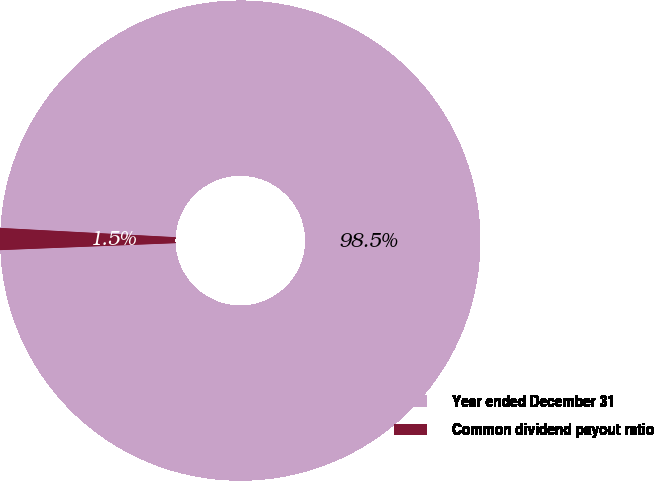<chart> <loc_0><loc_0><loc_500><loc_500><pie_chart><fcel>Year ended December 31<fcel>Common dividend payout ratio<nl><fcel>98.53%<fcel>1.47%<nl></chart> 